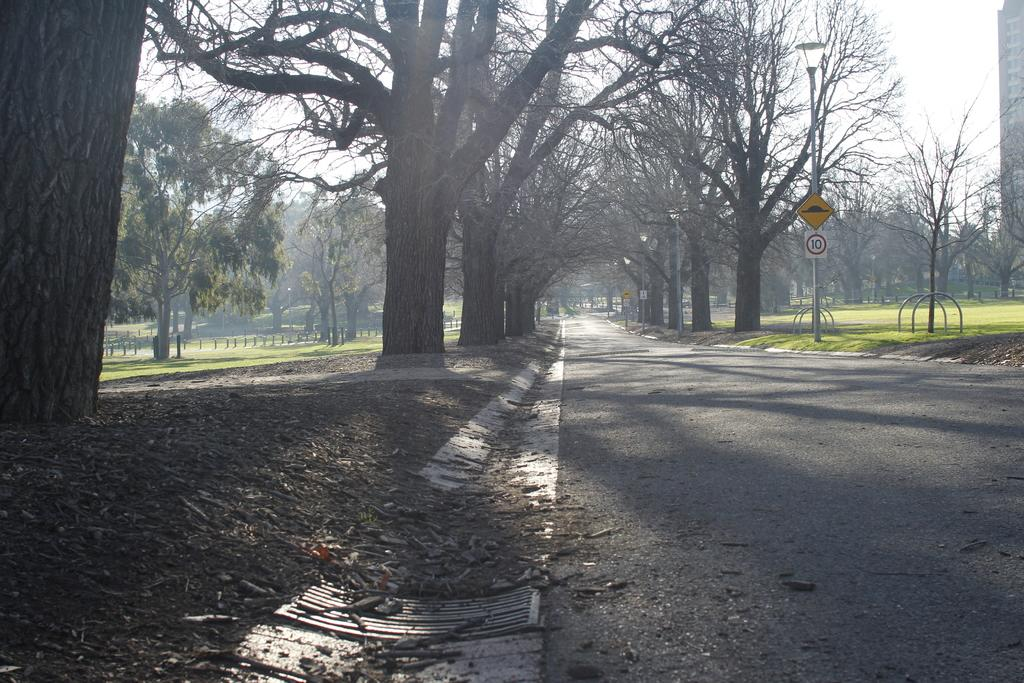What can be seen on the right side of the image? There is a road on the right side of the image. What is located near the road in the image? Trees are present on either side of the road in a garden. What is visible above the road in the image? The sky is visible above the road. What type of yam is growing in the garden next to the road? There is no yam present in the image; the garden contains trees. 